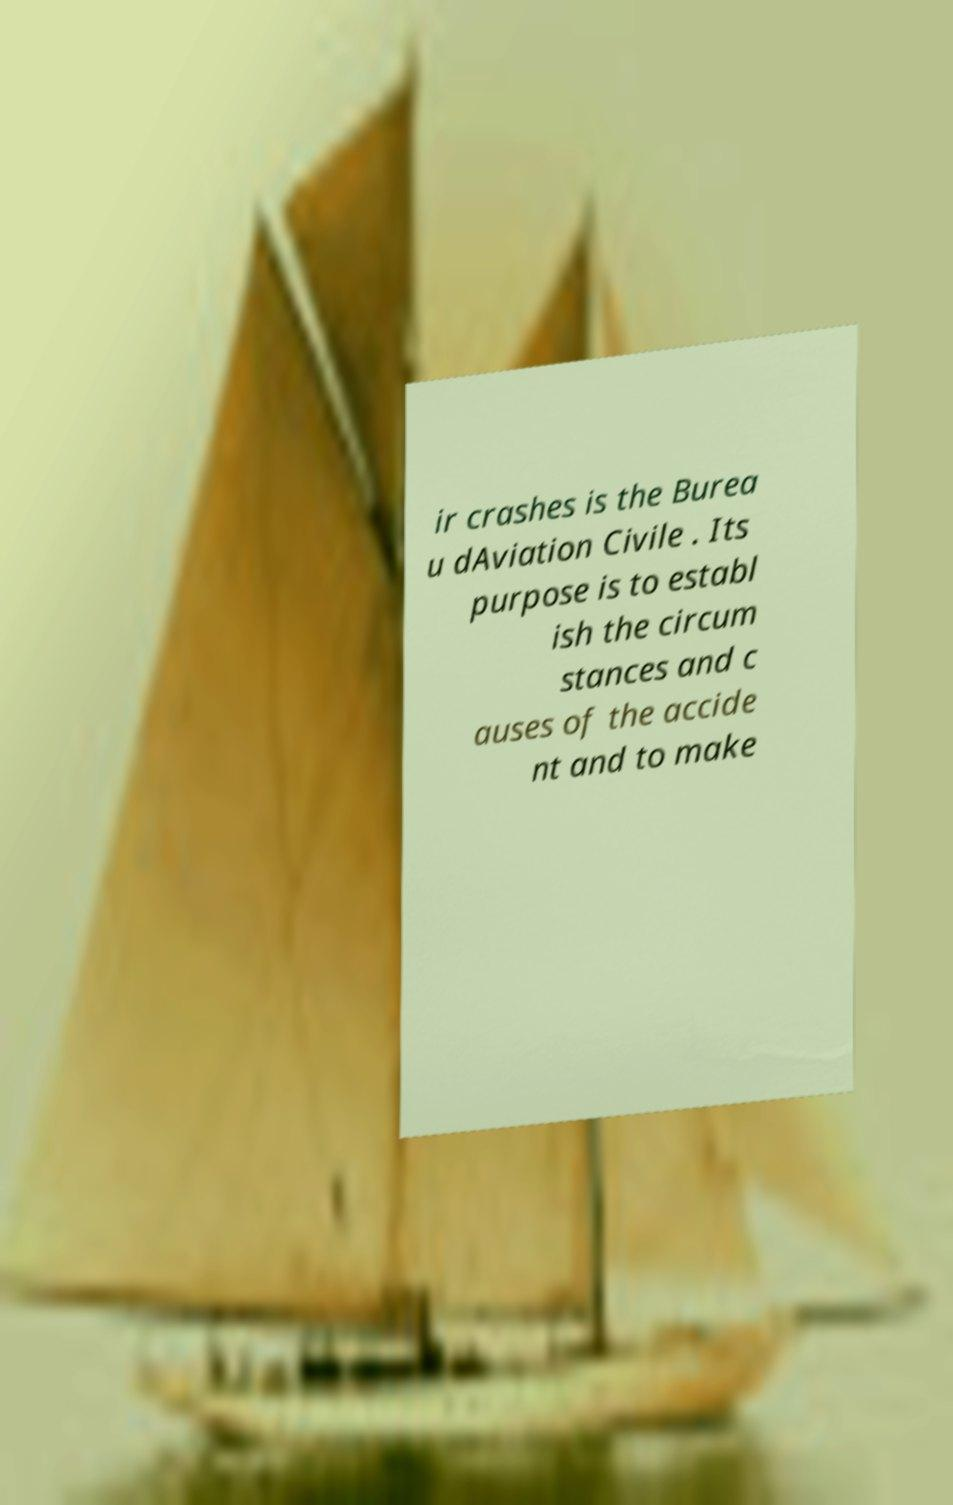What messages or text are displayed in this image? I need them in a readable, typed format. ir crashes is the Burea u dAviation Civile . Its purpose is to establ ish the circum stances and c auses of the accide nt and to make 